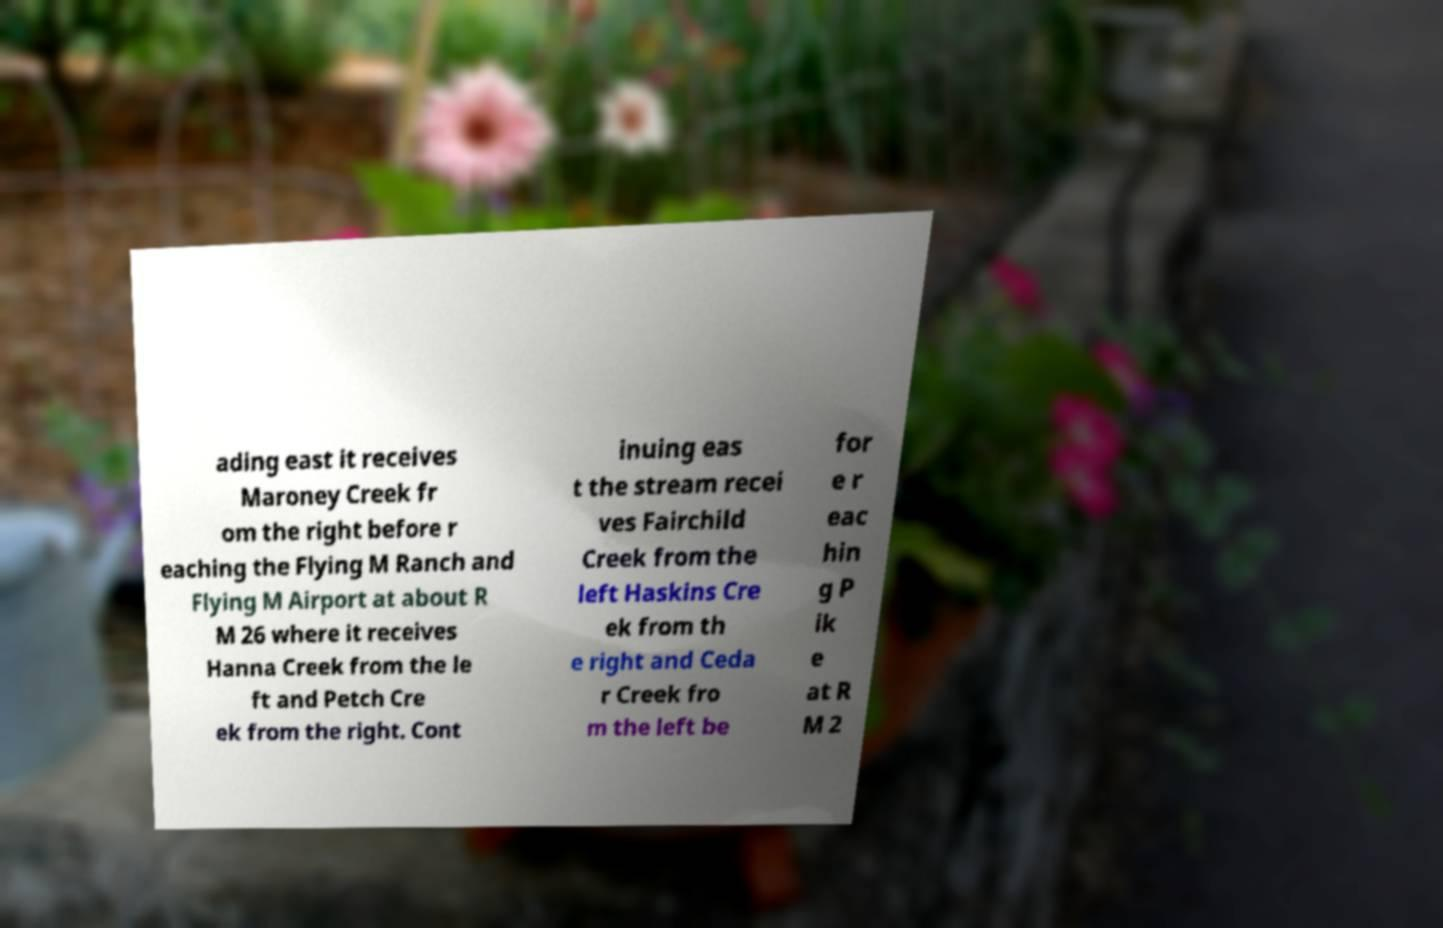Please identify and transcribe the text found in this image. ading east it receives Maroney Creek fr om the right before r eaching the Flying M Ranch and Flying M Airport at about R M 26 where it receives Hanna Creek from the le ft and Petch Cre ek from the right. Cont inuing eas t the stream recei ves Fairchild Creek from the left Haskins Cre ek from th e right and Ceda r Creek fro m the left be for e r eac hin g P ik e at R M 2 